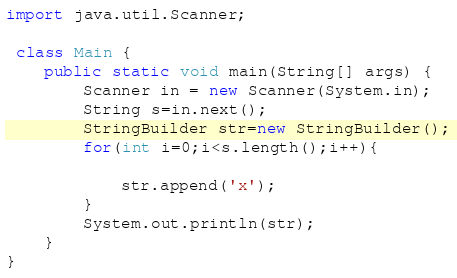<code> <loc_0><loc_0><loc_500><loc_500><_Java_>
import java.util.Scanner;

 class Main {
    public static void main(String[] args) {
        Scanner in = new Scanner(System.in);
        String s=in.next();
        StringBuilder str=new StringBuilder();
        for(int i=0;i<s.length();i++){

            str.append('x');
        }
        System.out.println(str);
    }
}
</code> 